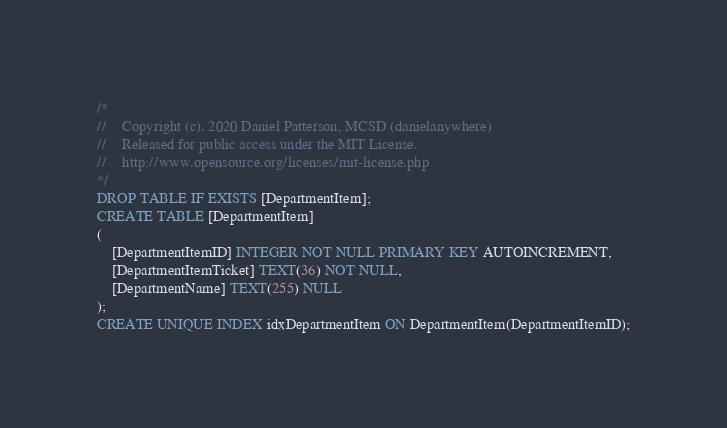<code> <loc_0><loc_0><loc_500><loc_500><_SQL_>/*
//	Copyright (c). 2020 Daniel Patterson, MCSD (danielanywhere)
//	Released for public access under the MIT License.
//	http://www.opensource.org/licenses/mit-license.php
*/
DROP TABLE IF EXISTS [DepartmentItem];
CREATE TABLE [DepartmentItem]
(
	[DepartmentItemID] INTEGER NOT NULL PRIMARY KEY AUTOINCREMENT,
	[DepartmentItemTicket] TEXT(36) NOT NULL,
	[DepartmentName] TEXT(255) NULL
);
CREATE UNIQUE INDEX idxDepartmentItem ON DepartmentItem(DepartmentItemID);
</code> 